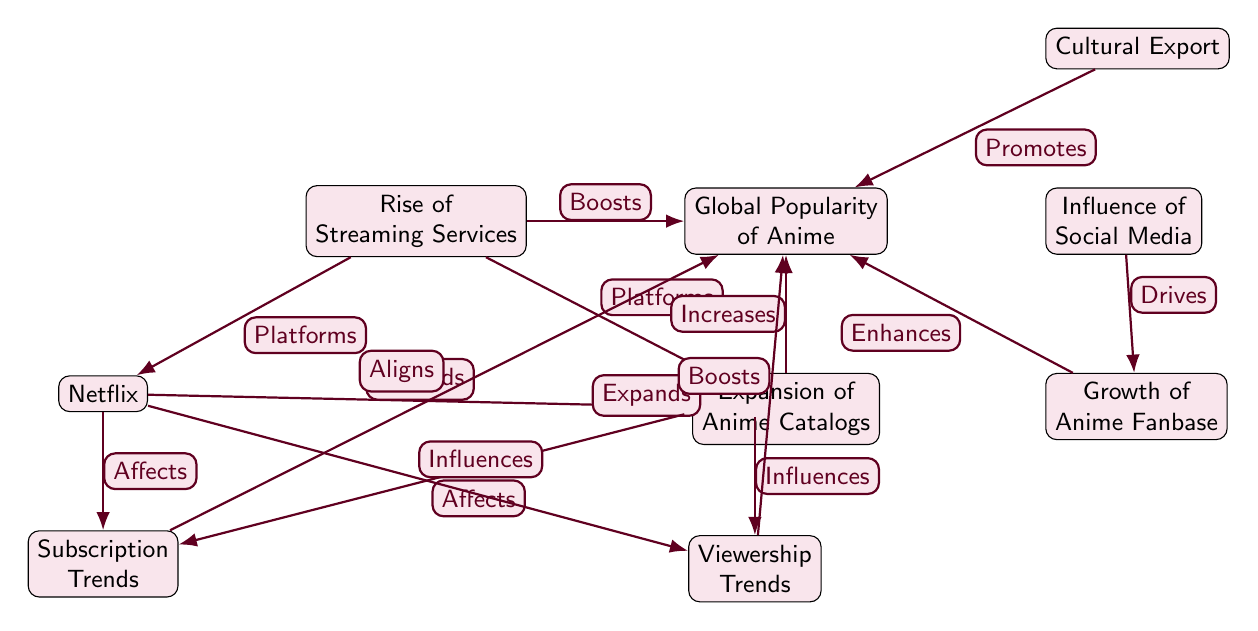What is the main factor boosting the popularity of anime? The diagram indicates that the "Rise of Streaming Services" is the primary factor that boosts the global popularity of anime, depicted by the directed edge from "Rise of Streaming Services" to "Global Popularity of Anime".
Answer: Rise of Streaming Services How many platforms are mentioned in the diagram? The diagram identifies two platforms specifically: "Netflix" and "Crunchyroll". Therefore, when counted, the answer is two.
Answer: 2 What is the relationship between Netflix and subscription trends? According to the diagram, Netflix "Affects" subscription trends as indicated by the directed edge from "Netflix" to "Subscription Trends".
Answer: Affects Which node expands the anime catalogs? Both "Netflix" and "Crunchyroll" contribute to the "Expansion of Anime Catalogs", as shown by the edges directed from these platforms to the "Expansion of Anime Catalogs" node.
Answer: Expansion of Anime Catalogs What drives anime fanbase growth? The diagram states that "Social Media Influence" drives the growth of the anime fanbase, represented by an edge labeled "Drives" from "Social Media Influence" to "Growth of Anime Fanbase".
Answer: Social Media Influence How does viewership trends contribute to the popularity of anime? Viewership trends are depicted as boosting the popularity of anime through an edge labeled "Boosts" that connects "Viewership Trends" to "Global Popularity of Anime".
Answer: Boosts Which node represents cultural factors influencing anime popularity? "Cultural Export" is identified in the diagram as a node that promotes the popularity of anime, indicated by the edge labeled "Promotes" connecting it to "Global Popularity of Anime".
Answer: Cultural Export What influences viewership trends according to the diagram? Both "Netflix" and "Crunchyroll" influence viewership trends as depicted by the edges labeled "Influences" originating from these platforms and pointing to "Viewership Trends".
Answer: Netflix and Crunchyroll How does subscription data relate to the popularity of anime? The diagram shows a directed edge labeled "Aligns" from "Subscription Trends" to "Global Popularity of Anime", indicating that subscription data aligns with the popularity of anime.
Answer: Aligns 